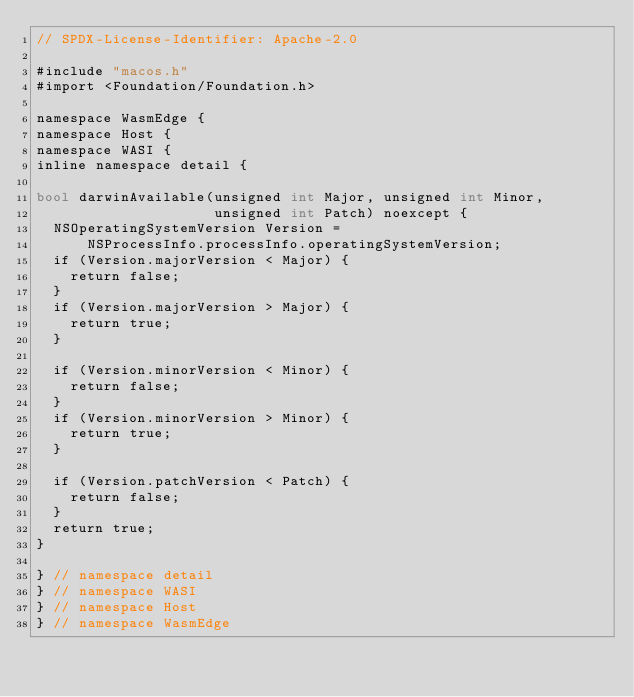Convert code to text. <code><loc_0><loc_0><loc_500><loc_500><_ObjectiveC_>// SPDX-License-Identifier: Apache-2.0

#include "macos.h"
#import <Foundation/Foundation.h>

namespace WasmEdge {
namespace Host {
namespace WASI {
inline namespace detail {

bool darwinAvailable(unsigned int Major, unsigned int Minor,
                     unsigned int Patch) noexcept {
  NSOperatingSystemVersion Version =
      NSProcessInfo.processInfo.operatingSystemVersion;
  if (Version.majorVersion < Major) {
    return false;
  }
  if (Version.majorVersion > Major) {
    return true;
  }

  if (Version.minorVersion < Minor) {
    return false;
  }
  if (Version.minorVersion > Minor) {
    return true;
  }

  if (Version.patchVersion < Patch) {
    return false;
  }
  return true;
}

} // namespace detail
} // namespace WASI
} // namespace Host
} // namespace WasmEdge
</code> 